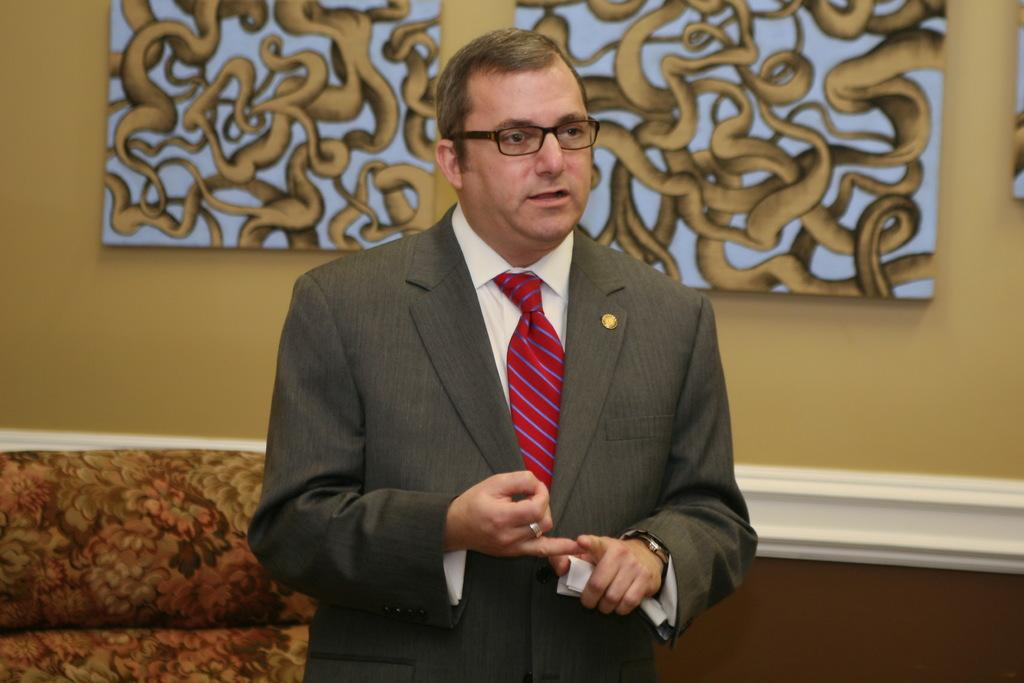Who is present in the image? There is a man in the image. What accessory is the man wearing? The man is wearing spectacles. What can be seen on the wall behind the man? There are paintings on the wall behind the man. What type of hat is the stranger wearing in the image? There is no stranger present in the image, and the man in the image is not wearing a hat. 